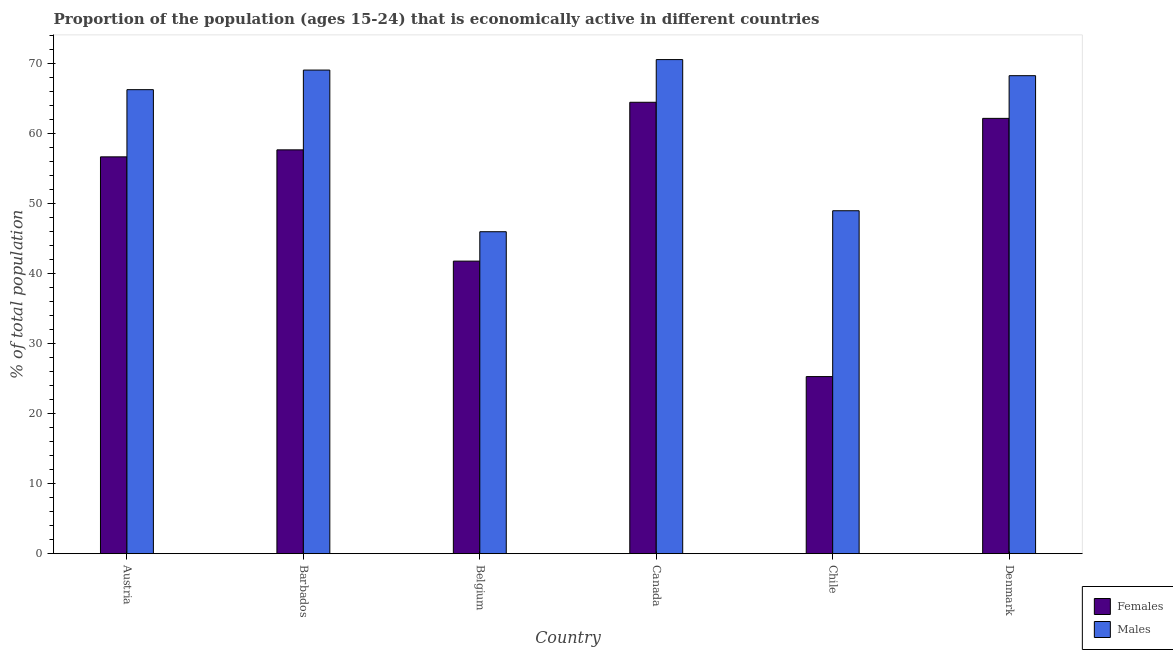How many groups of bars are there?
Offer a very short reply. 6. Are the number of bars on each tick of the X-axis equal?
Ensure brevity in your answer.  Yes. How many bars are there on the 1st tick from the left?
Your answer should be compact. 2. What is the percentage of economically active male population in Belgium?
Your response must be concise. 46. Across all countries, what is the maximum percentage of economically active female population?
Offer a terse response. 64.5. In which country was the percentage of economically active female population maximum?
Offer a very short reply. Canada. What is the total percentage of economically active male population in the graph?
Give a very brief answer. 369.3. What is the difference between the percentage of economically active male population in Barbados and that in Chile?
Ensure brevity in your answer.  20.1. What is the difference between the percentage of economically active male population in Chile and the percentage of economically active female population in Barbados?
Your answer should be very brief. -8.7. What is the average percentage of economically active female population per country?
Ensure brevity in your answer.  51.37. What is the difference between the percentage of economically active male population and percentage of economically active female population in Chile?
Make the answer very short. 23.7. In how many countries, is the percentage of economically active female population greater than 8 %?
Your answer should be very brief. 6. What is the ratio of the percentage of economically active male population in Canada to that in Denmark?
Your answer should be compact. 1.03. What is the difference between the highest and the second highest percentage of economically active female population?
Offer a terse response. 2.3. What is the difference between the highest and the lowest percentage of economically active male population?
Your answer should be very brief. 24.6. In how many countries, is the percentage of economically active female population greater than the average percentage of economically active female population taken over all countries?
Keep it short and to the point. 4. Is the sum of the percentage of economically active male population in Barbados and Chile greater than the maximum percentage of economically active female population across all countries?
Offer a very short reply. Yes. What does the 2nd bar from the left in Barbados represents?
Your answer should be very brief. Males. What does the 2nd bar from the right in Austria represents?
Give a very brief answer. Females. How many countries are there in the graph?
Provide a short and direct response. 6. Are the values on the major ticks of Y-axis written in scientific E-notation?
Your answer should be compact. No. Where does the legend appear in the graph?
Offer a very short reply. Bottom right. How are the legend labels stacked?
Provide a succinct answer. Vertical. What is the title of the graph?
Keep it short and to the point. Proportion of the population (ages 15-24) that is economically active in different countries. What is the label or title of the X-axis?
Offer a very short reply. Country. What is the label or title of the Y-axis?
Ensure brevity in your answer.  % of total population. What is the % of total population in Females in Austria?
Ensure brevity in your answer.  56.7. What is the % of total population of Males in Austria?
Your answer should be compact. 66.3. What is the % of total population in Females in Barbados?
Ensure brevity in your answer.  57.7. What is the % of total population in Males in Barbados?
Your answer should be compact. 69.1. What is the % of total population of Females in Belgium?
Make the answer very short. 41.8. What is the % of total population in Females in Canada?
Your response must be concise. 64.5. What is the % of total population in Males in Canada?
Give a very brief answer. 70.6. What is the % of total population in Females in Chile?
Give a very brief answer. 25.3. What is the % of total population in Males in Chile?
Ensure brevity in your answer.  49. What is the % of total population of Females in Denmark?
Make the answer very short. 62.2. What is the % of total population of Males in Denmark?
Offer a very short reply. 68.3. Across all countries, what is the maximum % of total population of Females?
Offer a very short reply. 64.5. Across all countries, what is the maximum % of total population of Males?
Your answer should be compact. 70.6. Across all countries, what is the minimum % of total population of Females?
Ensure brevity in your answer.  25.3. What is the total % of total population in Females in the graph?
Your answer should be compact. 308.2. What is the total % of total population of Males in the graph?
Your answer should be very brief. 369.3. What is the difference between the % of total population in Males in Austria and that in Belgium?
Make the answer very short. 20.3. What is the difference between the % of total population of Females in Austria and that in Canada?
Keep it short and to the point. -7.8. What is the difference between the % of total population in Females in Austria and that in Chile?
Offer a very short reply. 31.4. What is the difference between the % of total population of Females in Austria and that in Denmark?
Make the answer very short. -5.5. What is the difference between the % of total population in Males in Austria and that in Denmark?
Offer a very short reply. -2. What is the difference between the % of total population of Males in Barbados and that in Belgium?
Offer a very short reply. 23.1. What is the difference between the % of total population of Males in Barbados and that in Canada?
Offer a very short reply. -1.5. What is the difference between the % of total population of Females in Barbados and that in Chile?
Your answer should be very brief. 32.4. What is the difference between the % of total population in Males in Barbados and that in Chile?
Give a very brief answer. 20.1. What is the difference between the % of total population of Males in Barbados and that in Denmark?
Offer a terse response. 0.8. What is the difference between the % of total population in Females in Belgium and that in Canada?
Offer a very short reply. -22.7. What is the difference between the % of total population in Males in Belgium and that in Canada?
Ensure brevity in your answer.  -24.6. What is the difference between the % of total population of Females in Belgium and that in Chile?
Offer a terse response. 16.5. What is the difference between the % of total population in Females in Belgium and that in Denmark?
Your response must be concise. -20.4. What is the difference between the % of total population of Males in Belgium and that in Denmark?
Ensure brevity in your answer.  -22.3. What is the difference between the % of total population of Females in Canada and that in Chile?
Your answer should be compact. 39.2. What is the difference between the % of total population of Males in Canada and that in Chile?
Keep it short and to the point. 21.6. What is the difference between the % of total population in Females in Canada and that in Denmark?
Your answer should be compact. 2.3. What is the difference between the % of total population in Males in Canada and that in Denmark?
Provide a short and direct response. 2.3. What is the difference between the % of total population of Females in Chile and that in Denmark?
Make the answer very short. -36.9. What is the difference between the % of total population in Males in Chile and that in Denmark?
Provide a succinct answer. -19.3. What is the difference between the % of total population of Females in Austria and the % of total population of Males in Barbados?
Your answer should be very brief. -12.4. What is the difference between the % of total population of Females in Austria and the % of total population of Males in Belgium?
Your answer should be very brief. 10.7. What is the difference between the % of total population in Females in Austria and the % of total population in Males in Canada?
Offer a terse response. -13.9. What is the difference between the % of total population of Females in Austria and the % of total population of Males in Chile?
Your answer should be compact. 7.7. What is the difference between the % of total population in Females in Austria and the % of total population in Males in Denmark?
Your response must be concise. -11.6. What is the difference between the % of total population of Females in Barbados and the % of total population of Males in Denmark?
Offer a terse response. -10.6. What is the difference between the % of total population in Females in Belgium and the % of total population in Males in Canada?
Provide a short and direct response. -28.8. What is the difference between the % of total population of Females in Belgium and the % of total population of Males in Denmark?
Provide a short and direct response. -26.5. What is the difference between the % of total population of Females in Canada and the % of total population of Males in Chile?
Your answer should be compact. 15.5. What is the difference between the % of total population in Females in Chile and the % of total population in Males in Denmark?
Make the answer very short. -43. What is the average % of total population of Females per country?
Give a very brief answer. 51.37. What is the average % of total population in Males per country?
Offer a very short reply. 61.55. What is the difference between the % of total population in Females and % of total population in Males in Barbados?
Your response must be concise. -11.4. What is the difference between the % of total population in Females and % of total population in Males in Belgium?
Offer a very short reply. -4.2. What is the difference between the % of total population of Females and % of total population of Males in Canada?
Make the answer very short. -6.1. What is the difference between the % of total population in Females and % of total population in Males in Chile?
Your response must be concise. -23.7. What is the ratio of the % of total population of Females in Austria to that in Barbados?
Your answer should be compact. 0.98. What is the ratio of the % of total population of Males in Austria to that in Barbados?
Make the answer very short. 0.96. What is the ratio of the % of total population in Females in Austria to that in Belgium?
Provide a short and direct response. 1.36. What is the ratio of the % of total population of Males in Austria to that in Belgium?
Give a very brief answer. 1.44. What is the ratio of the % of total population in Females in Austria to that in Canada?
Give a very brief answer. 0.88. What is the ratio of the % of total population in Males in Austria to that in Canada?
Your answer should be compact. 0.94. What is the ratio of the % of total population of Females in Austria to that in Chile?
Your response must be concise. 2.24. What is the ratio of the % of total population of Males in Austria to that in Chile?
Your answer should be very brief. 1.35. What is the ratio of the % of total population in Females in Austria to that in Denmark?
Give a very brief answer. 0.91. What is the ratio of the % of total population of Males in Austria to that in Denmark?
Provide a succinct answer. 0.97. What is the ratio of the % of total population of Females in Barbados to that in Belgium?
Your answer should be compact. 1.38. What is the ratio of the % of total population in Males in Barbados to that in Belgium?
Keep it short and to the point. 1.5. What is the ratio of the % of total population of Females in Barbados to that in Canada?
Provide a succinct answer. 0.89. What is the ratio of the % of total population of Males in Barbados to that in Canada?
Give a very brief answer. 0.98. What is the ratio of the % of total population in Females in Barbados to that in Chile?
Your answer should be very brief. 2.28. What is the ratio of the % of total population in Males in Barbados to that in Chile?
Keep it short and to the point. 1.41. What is the ratio of the % of total population in Females in Barbados to that in Denmark?
Your response must be concise. 0.93. What is the ratio of the % of total population in Males in Barbados to that in Denmark?
Offer a terse response. 1.01. What is the ratio of the % of total population in Females in Belgium to that in Canada?
Keep it short and to the point. 0.65. What is the ratio of the % of total population in Males in Belgium to that in Canada?
Ensure brevity in your answer.  0.65. What is the ratio of the % of total population in Females in Belgium to that in Chile?
Your answer should be very brief. 1.65. What is the ratio of the % of total population in Males in Belgium to that in Chile?
Make the answer very short. 0.94. What is the ratio of the % of total population of Females in Belgium to that in Denmark?
Keep it short and to the point. 0.67. What is the ratio of the % of total population of Males in Belgium to that in Denmark?
Offer a very short reply. 0.67. What is the ratio of the % of total population of Females in Canada to that in Chile?
Give a very brief answer. 2.55. What is the ratio of the % of total population of Males in Canada to that in Chile?
Provide a succinct answer. 1.44. What is the ratio of the % of total population of Males in Canada to that in Denmark?
Offer a very short reply. 1.03. What is the ratio of the % of total population of Females in Chile to that in Denmark?
Keep it short and to the point. 0.41. What is the ratio of the % of total population in Males in Chile to that in Denmark?
Provide a succinct answer. 0.72. What is the difference between the highest and the second highest % of total population of Males?
Offer a terse response. 1.5. What is the difference between the highest and the lowest % of total population of Females?
Make the answer very short. 39.2. What is the difference between the highest and the lowest % of total population of Males?
Your response must be concise. 24.6. 